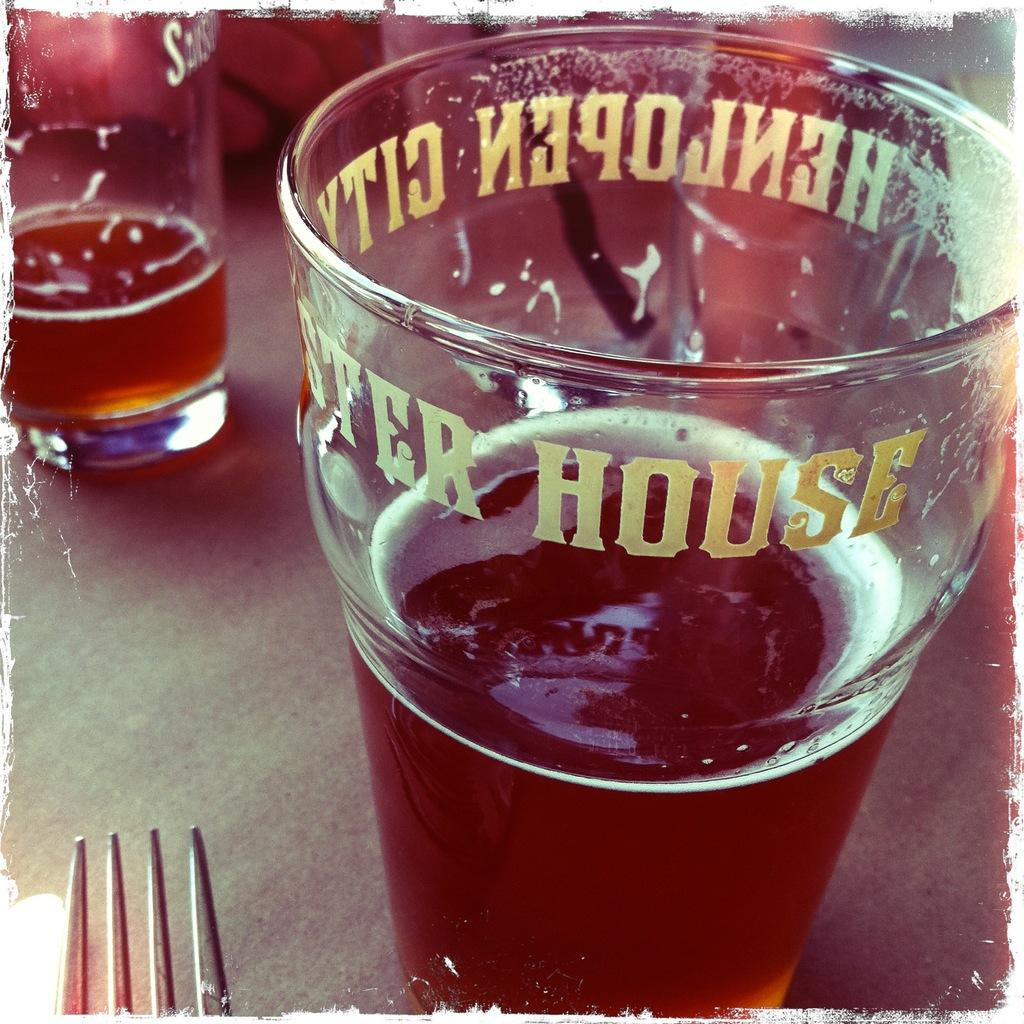What objects are in the image that are typically used for drinking? There are glasses in the image. What is inside the glasses? The glasses contain beer. What utensil is present in the image? There is a fork present in the image. Where are the glasses and fork located? The glasses and fork are on a table. How does the rake help control the swimming in the image? There is no rake or swimming present in the image. 